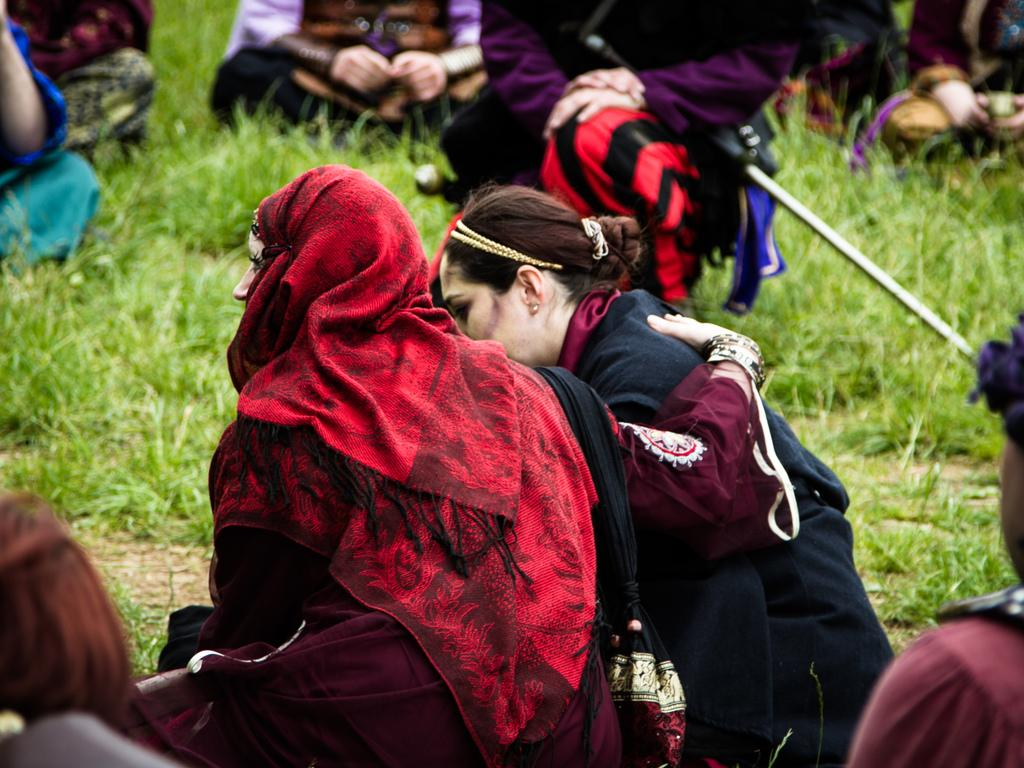How many people are in the image? There is a group of people in the image, but the exact number is not specified. What are the people sitting on in the image? The people are sitting on grass in the image. What items can be seen besides the people in the image? Handbags and a stick are present in the image. Where might this image have been taken? The image may have been taken in a park, given the presence of grass and possibly trees. What type of cherries are being eaten by the people in the image? There are no cherries present in the image; the people are sitting on grass. How many times does the person in the image sneeze? There is no indication of anyone sneezing in the image. 